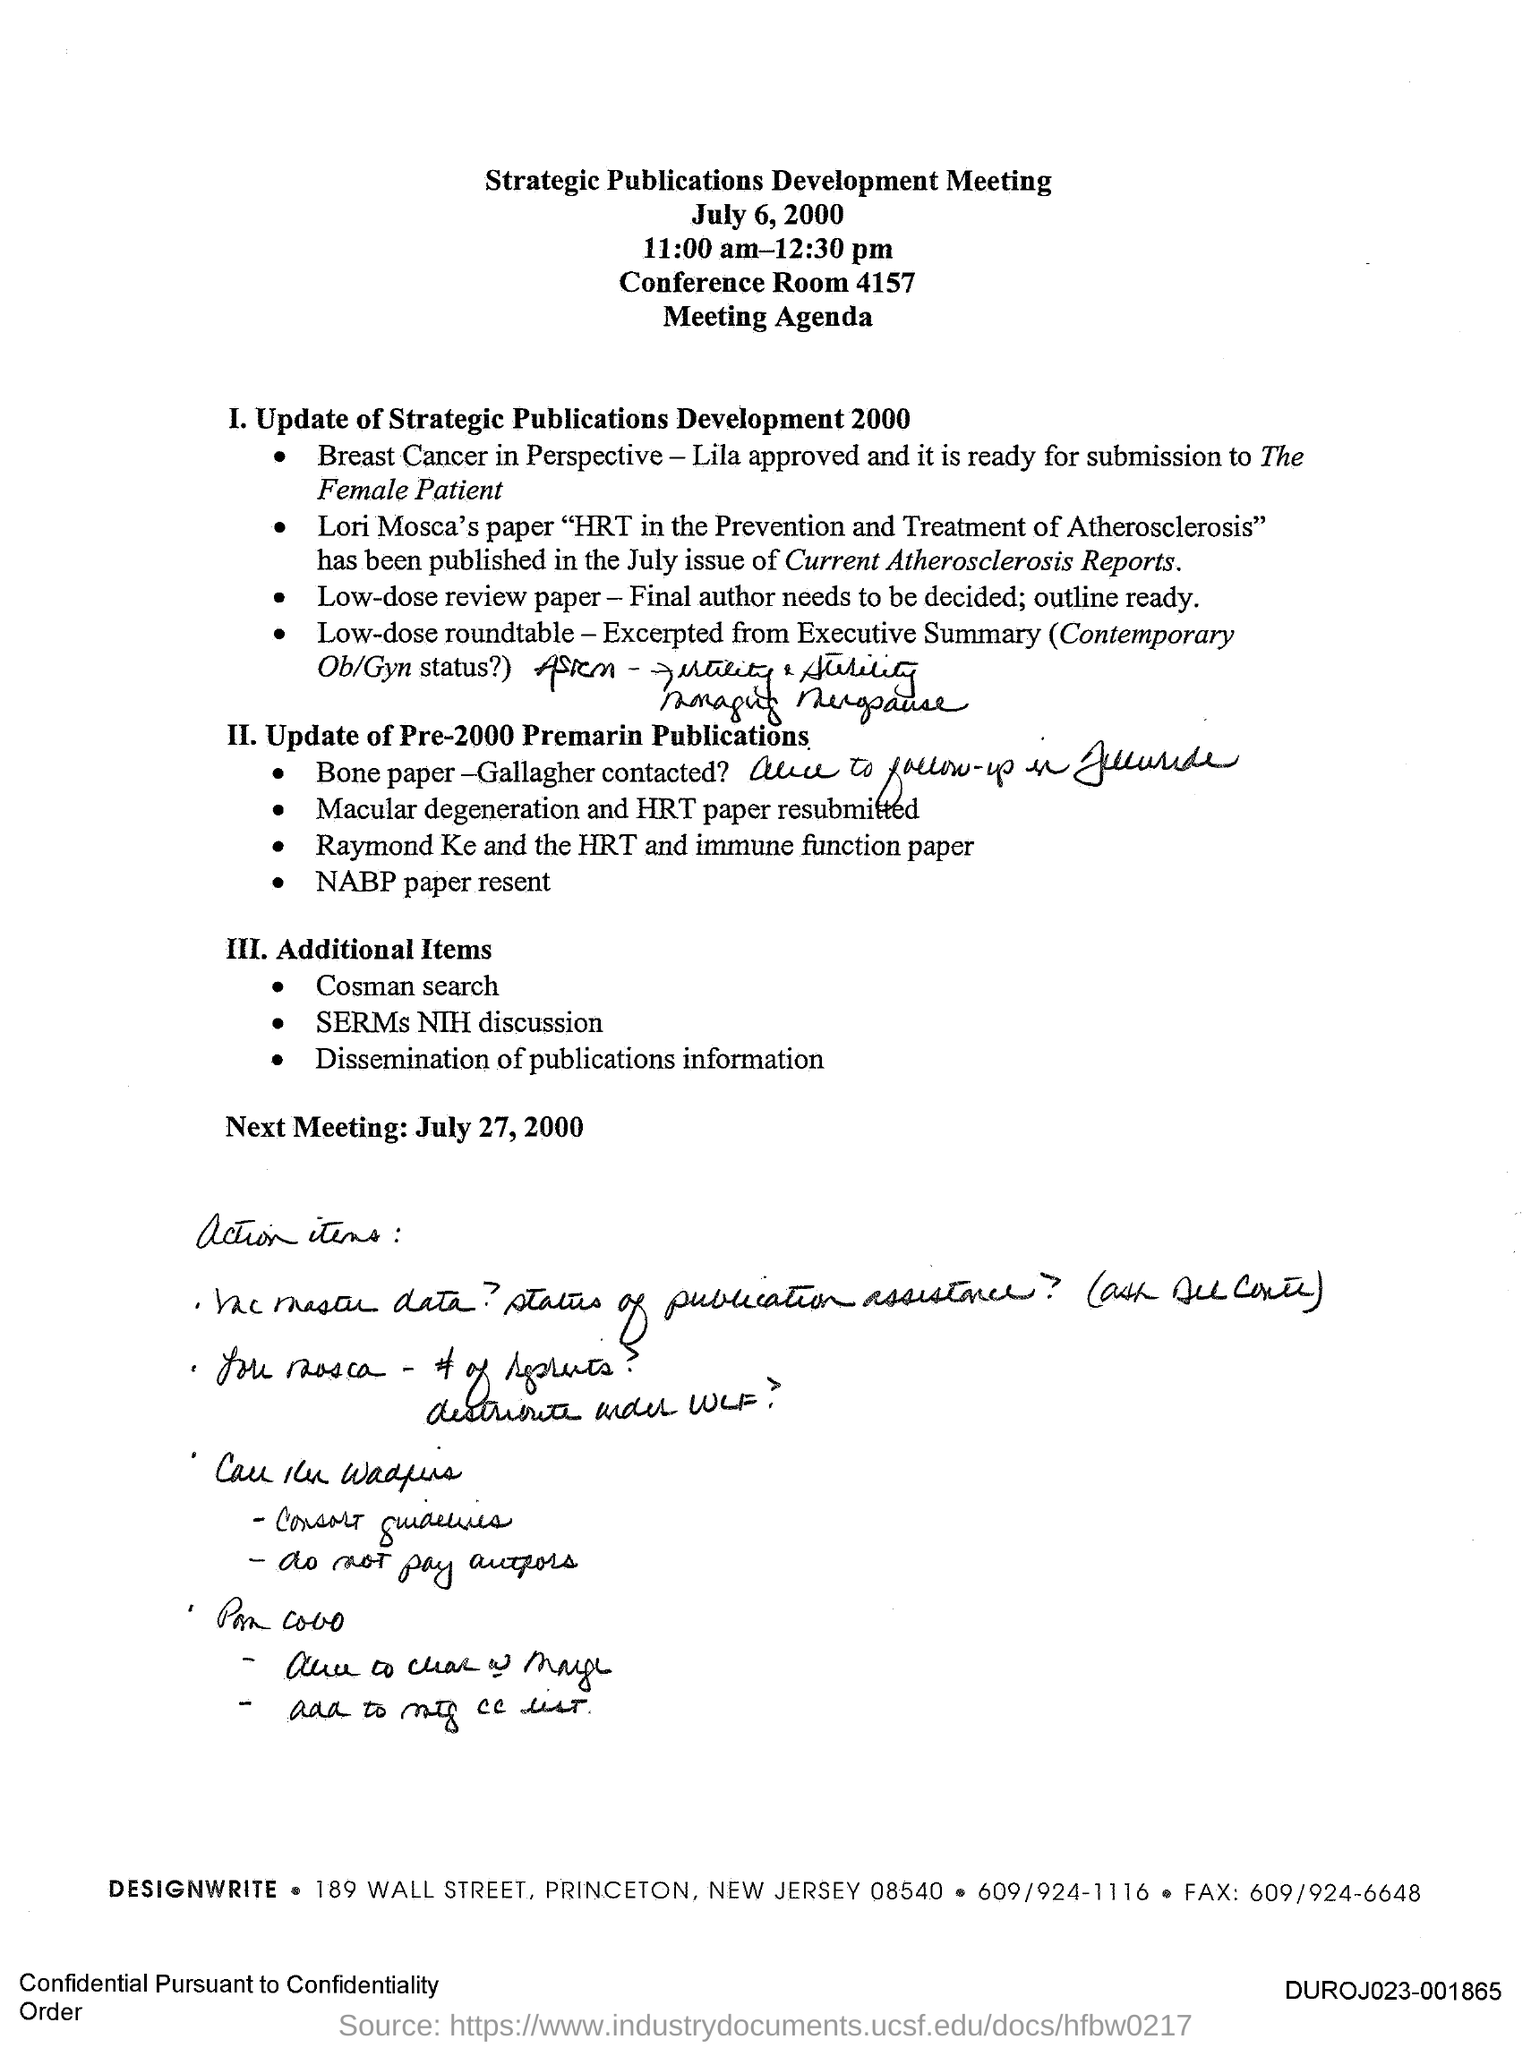Mention a couple of crucial points in this snapshot. The Strategic Publications Development Meeting was held on July 6, 2000. The next meeting is scheduled for July 27, 2000. The Strategic Publications Development Meeting is held in Conference Room 4157. 